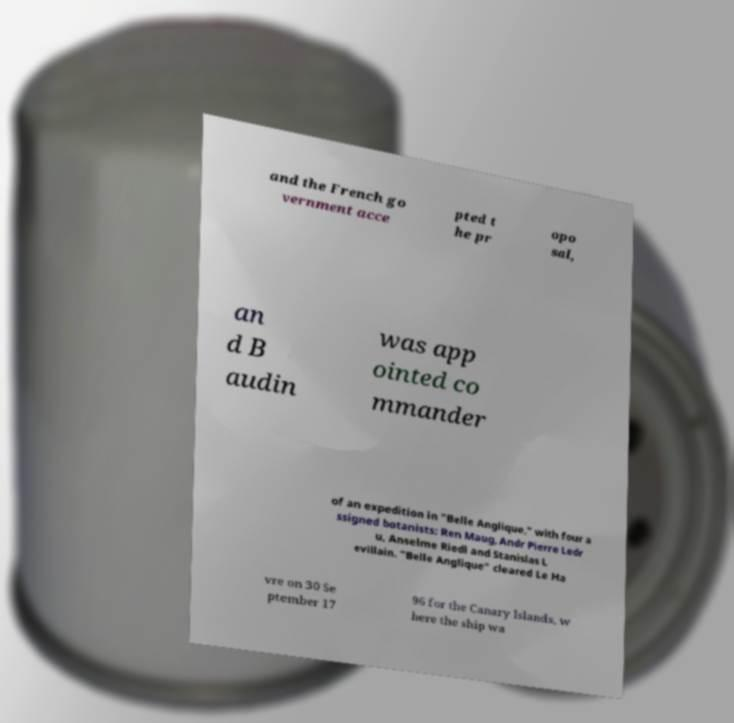There's text embedded in this image that I need extracted. Can you transcribe it verbatim? and the French go vernment acce pted t he pr opo sal, an d B audin was app ointed co mmander of an expedition in "Belle Anglique," with four a ssigned botanists: Ren Maug, Andr Pierre Ledr u, Anselme Riedl and Stanislas L evillain. "Belle Anglique" cleared Le Ha vre on 30 Se ptember 17 96 for the Canary Islands, w here the ship wa 